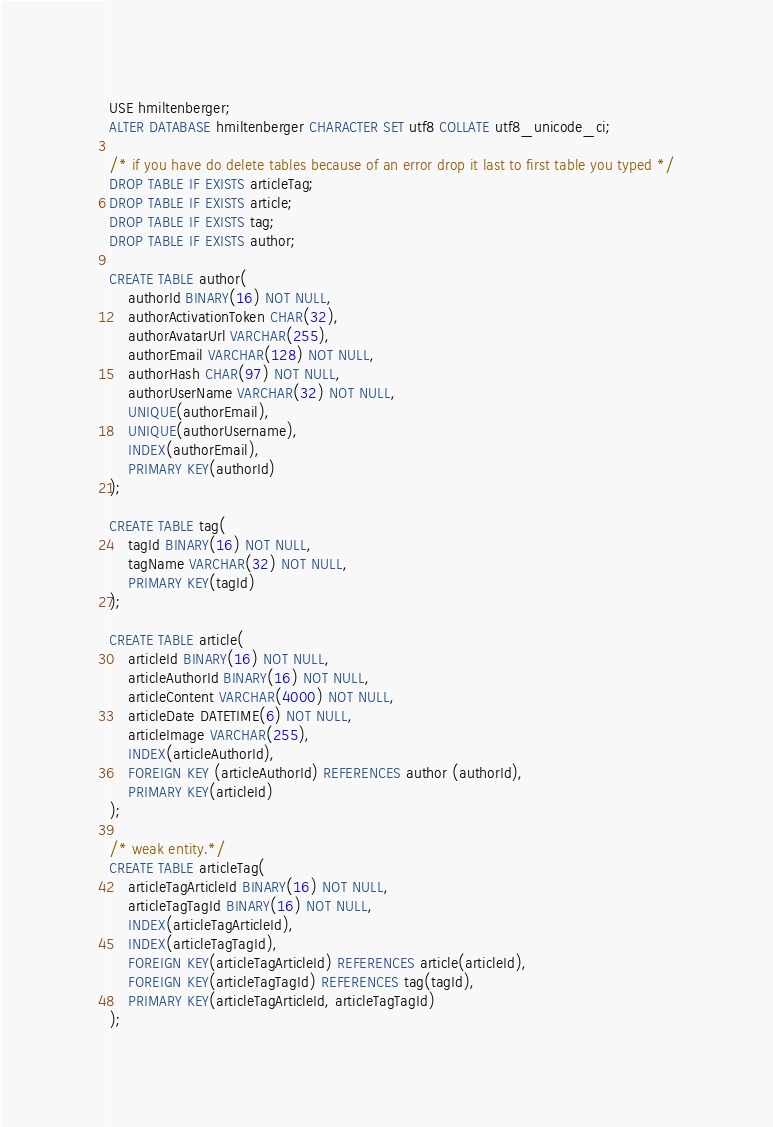Convert code to text. <code><loc_0><loc_0><loc_500><loc_500><_SQL_>USE hmiltenberger;
ALTER DATABASE hmiltenberger CHARACTER SET utf8 COLLATE utf8_unicode_ci;

/* if you have do delete tables because of an error drop it last to first table you typed */
DROP TABLE IF EXISTS articleTag;
DROP TABLE IF EXISTS article;
DROP TABLE IF EXISTS tag;
DROP TABLE IF EXISTS author;

CREATE TABLE author(
	authorId BINARY(16) NOT NULL,
	authorActivationToken CHAR(32),
	authorAvatarUrl VARCHAR(255),
	authorEmail VARCHAR(128) NOT NULL,
	authorHash CHAR(97) NOT NULL,
	authorUserName VARCHAR(32) NOT NULL,
	UNIQUE(authorEmail),
	UNIQUE(authorUsername),
	INDEX(authorEmail),
	PRIMARY KEY(authorId)
);

CREATE TABLE tag(
	tagId BINARY(16) NOT NULL,
	tagName VARCHAR(32) NOT NULL,
	PRIMARY KEY(tagId)
);

CREATE TABLE article(
	articleId BINARY(16) NOT NULL,
	articleAuthorId BINARY(16) NOT NULL,
	articleContent VARCHAR(4000) NOT NULL,
	articleDate DATETIME(6) NOT NULL,
	articleImage VARCHAR(255),
	INDEX(articleAuthorId),
	FOREIGN KEY (articleAuthorId) REFERENCES author (authorId),
	PRIMARY KEY(articleId)
);

/* weak entity.*/
CREATE TABLE articleTag(
	articleTagArticleId BINARY(16) NOT NULL,
	articleTagTagId BINARY(16) NOT NULL,
	INDEX(articleTagArticleId),
	INDEX(articleTagTagId),
	FOREIGN KEY(articleTagArticleId) REFERENCES article(articleId),
	FOREIGN KEY(articleTagTagId) REFERENCES tag(tagId),
	PRIMARY KEY(articleTagArticleId, articleTagTagId)
);
</code> 